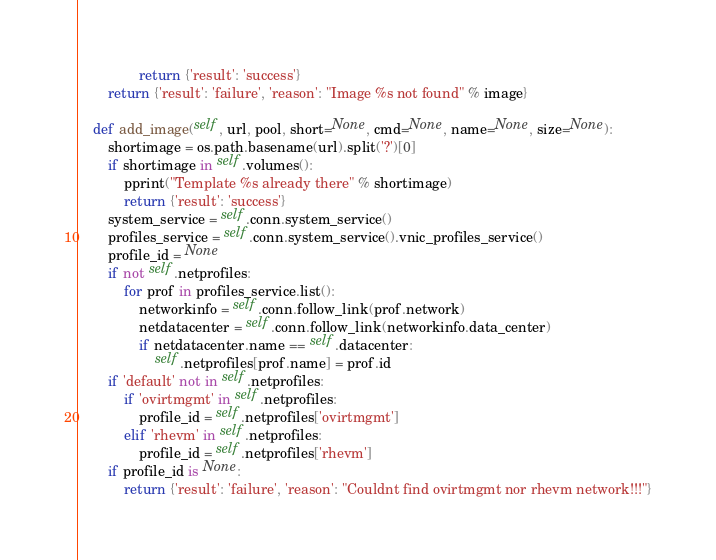Convert code to text. <code><loc_0><loc_0><loc_500><loc_500><_Python_>                return {'result': 'success'}
        return {'result': 'failure', 'reason': "Image %s not found" % image}

    def add_image(self, url, pool, short=None, cmd=None, name=None, size=None):
        shortimage = os.path.basename(url).split('?')[0]
        if shortimage in self.volumes():
            pprint("Template %s already there" % shortimage)
            return {'result': 'success'}
        system_service = self.conn.system_service()
        profiles_service = self.conn.system_service().vnic_profiles_service()
        profile_id = None
        if not self.netprofiles:
            for prof in profiles_service.list():
                networkinfo = self.conn.follow_link(prof.network)
                netdatacenter = self.conn.follow_link(networkinfo.data_center)
                if netdatacenter.name == self.datacenter:
                    self.netprofiles[prof.name] = prof.id
        if 'default' not in self.netprofiles:
            if 'ovirtmgmt' in self.netprofiles:
                profile_id = self.netprofiles['ovirtmgmt']
            elif 'rhevm' in self.netprofiles:
                profile_id = self.netprofiles['rhevm']
        if profile_id is None:
            return {'result': 'failure', 'reason': "Couldnt find ovirtmgmt nor rhevm network!!!"}</code> 